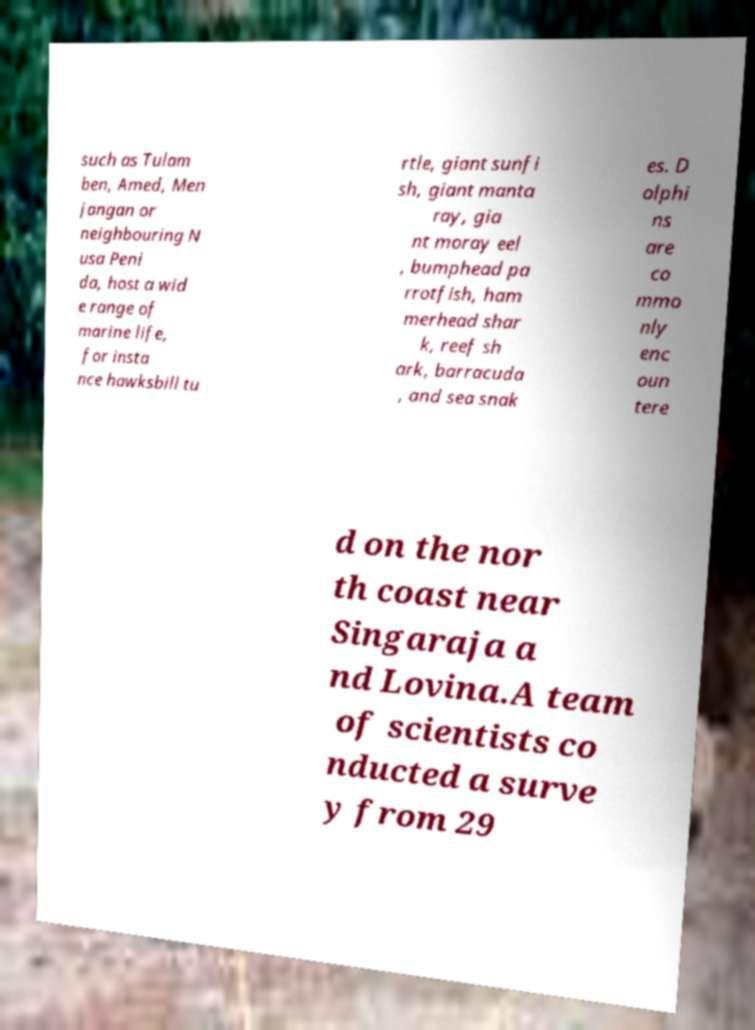Please identify and transcribe the text found in this image. such as Tulam ben, Amed, Men jangan or neighbouring N usa Peni da, host a wid e range of marine life, for insta nce hawksbill tu rtle, giant sunfi sh, giant manta ray, gia nt moray eel , bumphead pa rrotfish, ham merhead shar k, reef sh ark, barracuda , and sea snak es. D olphi ns are co mmo nly enc oun tere d on the nor th coast near Singaraja a nd Lovina.A team of scientists co nducted a surve y from 29 